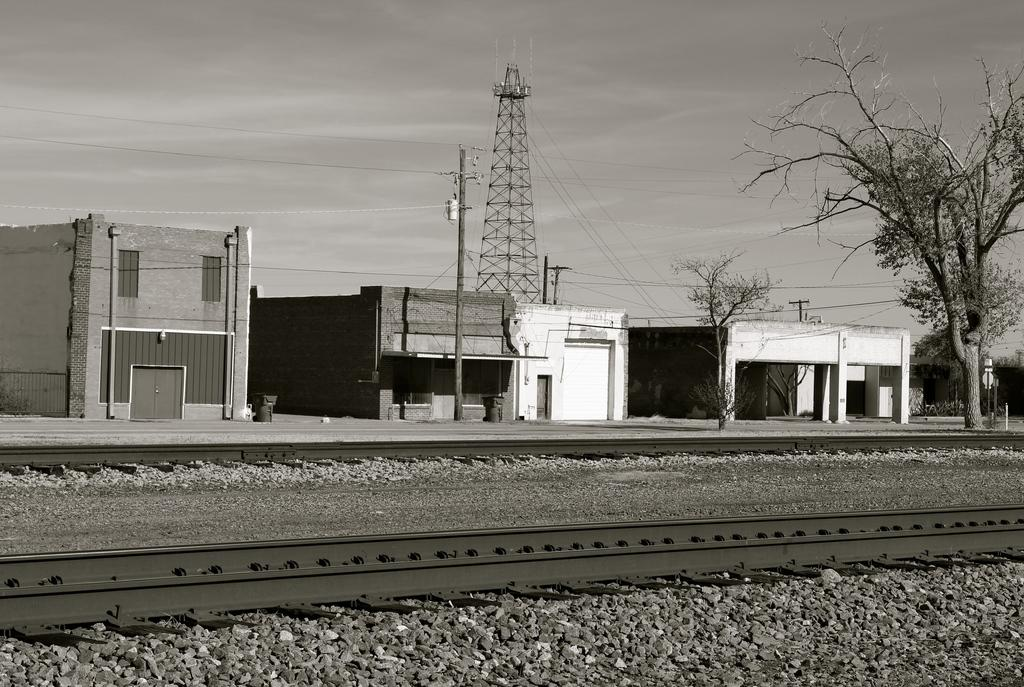What type of transportation infrastructure is present in the image? There is a railway track in the image. What can be seen on the ground in the image? There are stones on the path in the image. What structures can be seen in the background of the image? There are houses, poles, a tower, and trees visible in the background of the image. Where is the garden located in the image? There is no garden present in the image. What type of tray is being used to carry the trail in the image? There is no tray or trail present in the image. 